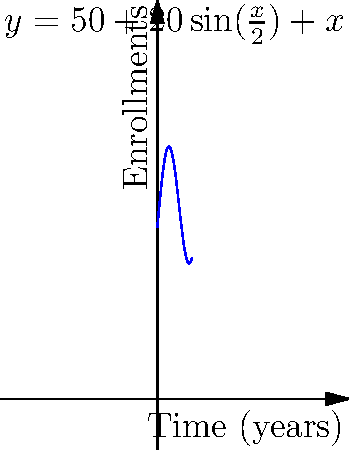The graph represents the number of enrollments in a witness protection program over time. The function is given by $y = 50 + 20\sin(\frac{x}{2}) + x$, where $y$ is the number of enrollments and $x$ is the time in years. At what point in time is the rate of change in enrollments at its maximum? To find the maximum rate of change, we need to follow these steps:

1) The rate of change is given by the derivative of the function. Let's calculate it:
   $$\frac{dy}{dx} = 20 \cdot \frac{1}{2}\cos(\frac{x}{2}) + 1 = 10\cos(\frac{x}{2}) + 1$$

2) The maximum rate of change occurs when the second derivative equals zero. Let's calculate the second derivative:
   $$\frac{d^2y}{dx^2} = 10 \cdot (-\frac{1}{2})\sin(\frac{x}{2}) = -5\sin(\frac{x}{2})$$

3) Set the second derivative to zero and solve:
   $$-5\sin(\frac{x}{2}) = 0$$
   $$\sin(\frac{x}{2}) = 0$$

4) The sine function equals zero when its argument is a multiple of π:
   $$\frac{x}{2} = n\pi, \text{ where } n \text{ is an integer}$$
   $$x = 2n\pi$$

5) The smallest positive value for x is when n = 1:
   $$x = 2\pi \approx 6.28 \text{ years}$$

6) To confirm this is a maximum (not minimum), check the sign of the third derivative at this point. If negative, it's a maximum.

Therefore, the rate of change in enrollments is at its maximum approximately 6.28 years after the start of the program.
Answer: 6.28 years 